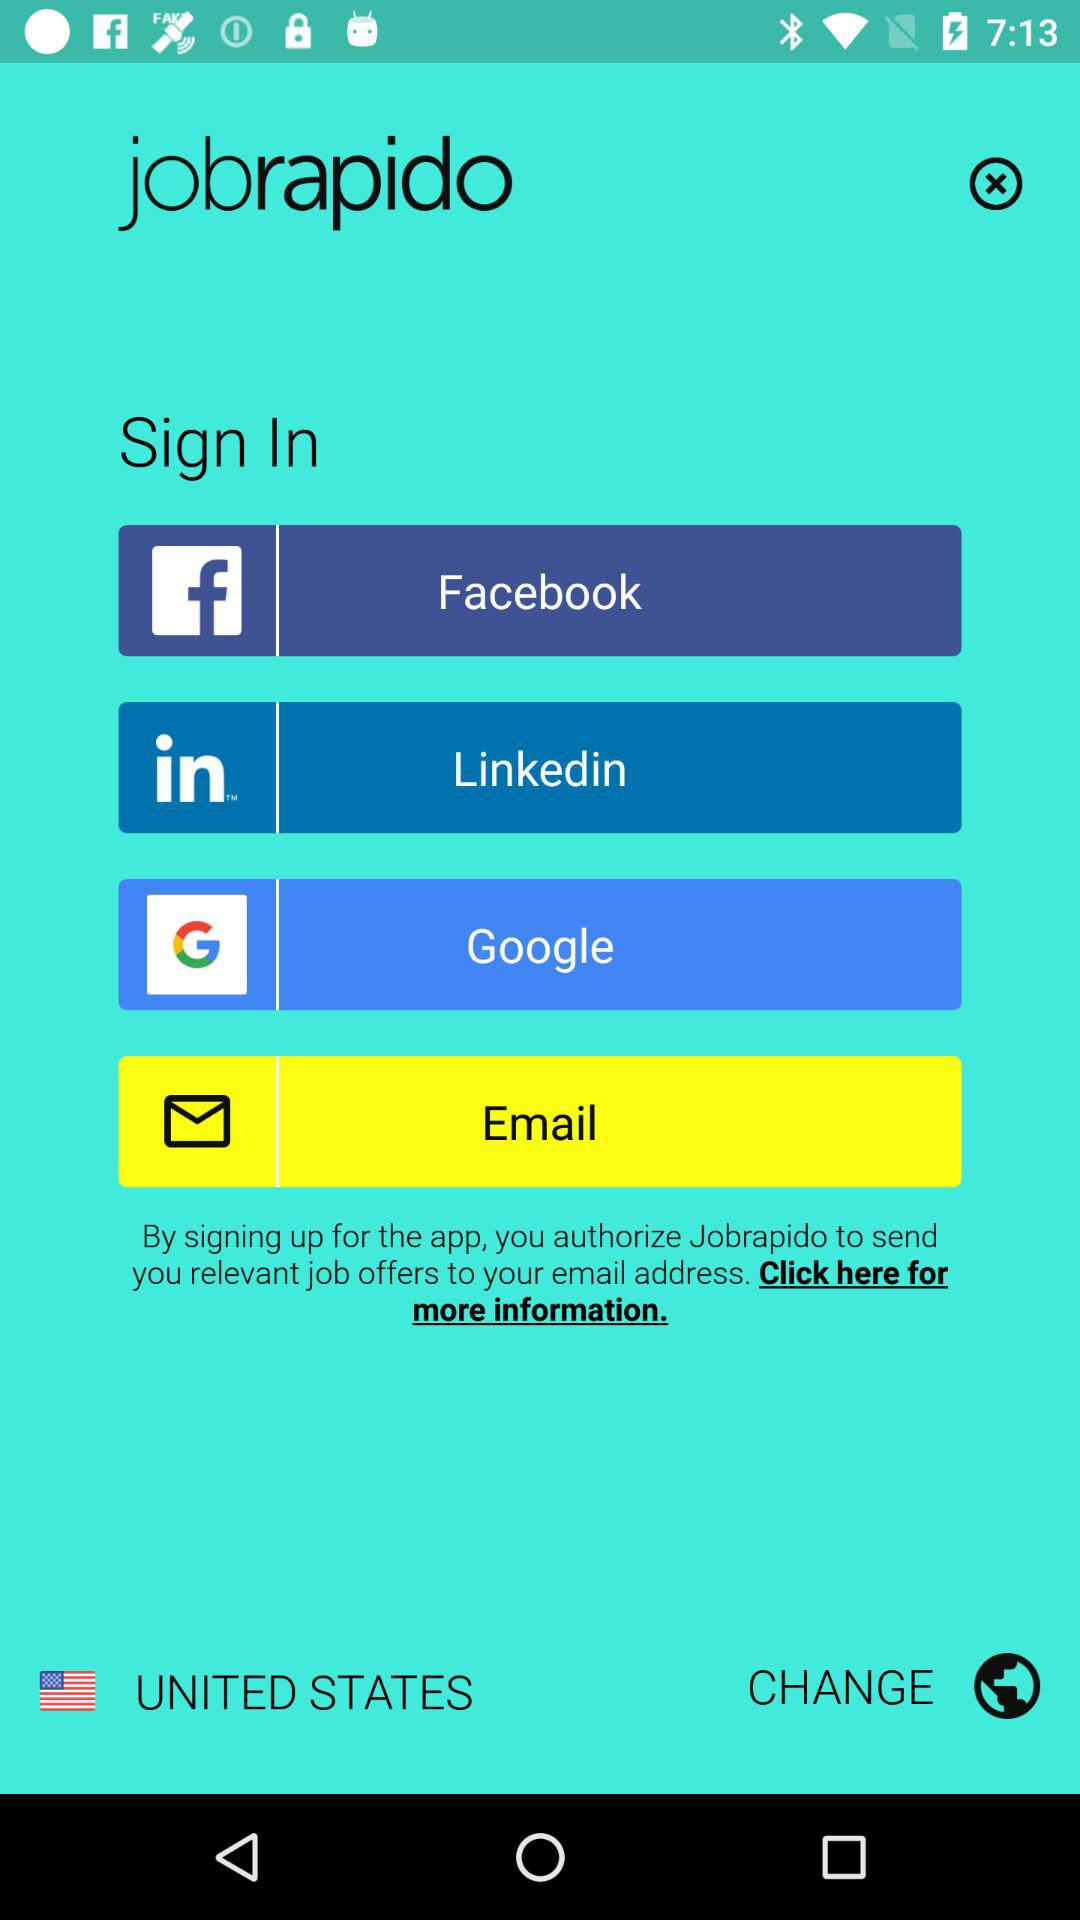Through which account can signing in be done? Signing in can be done through "Facebook", "Linkedin", "Google" and "Email" accounts. 